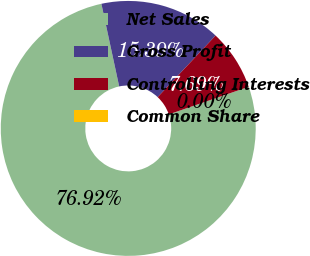<chart> <loc_0><loc_0><loc_500><loc_500><pie_chart><fcel>Net Sales<fcel>Gross Profit<fcel>Controlling Interests<fcel>Common Share<nl><fcel>76.92%<fcel>15.39%<fcel>7.69%<fcel>0.0%<nl></chart> 